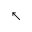Convert formula to latex. <formula><loc_0><loc_0><loc_500><loc_500>\nwarrow</formula> 